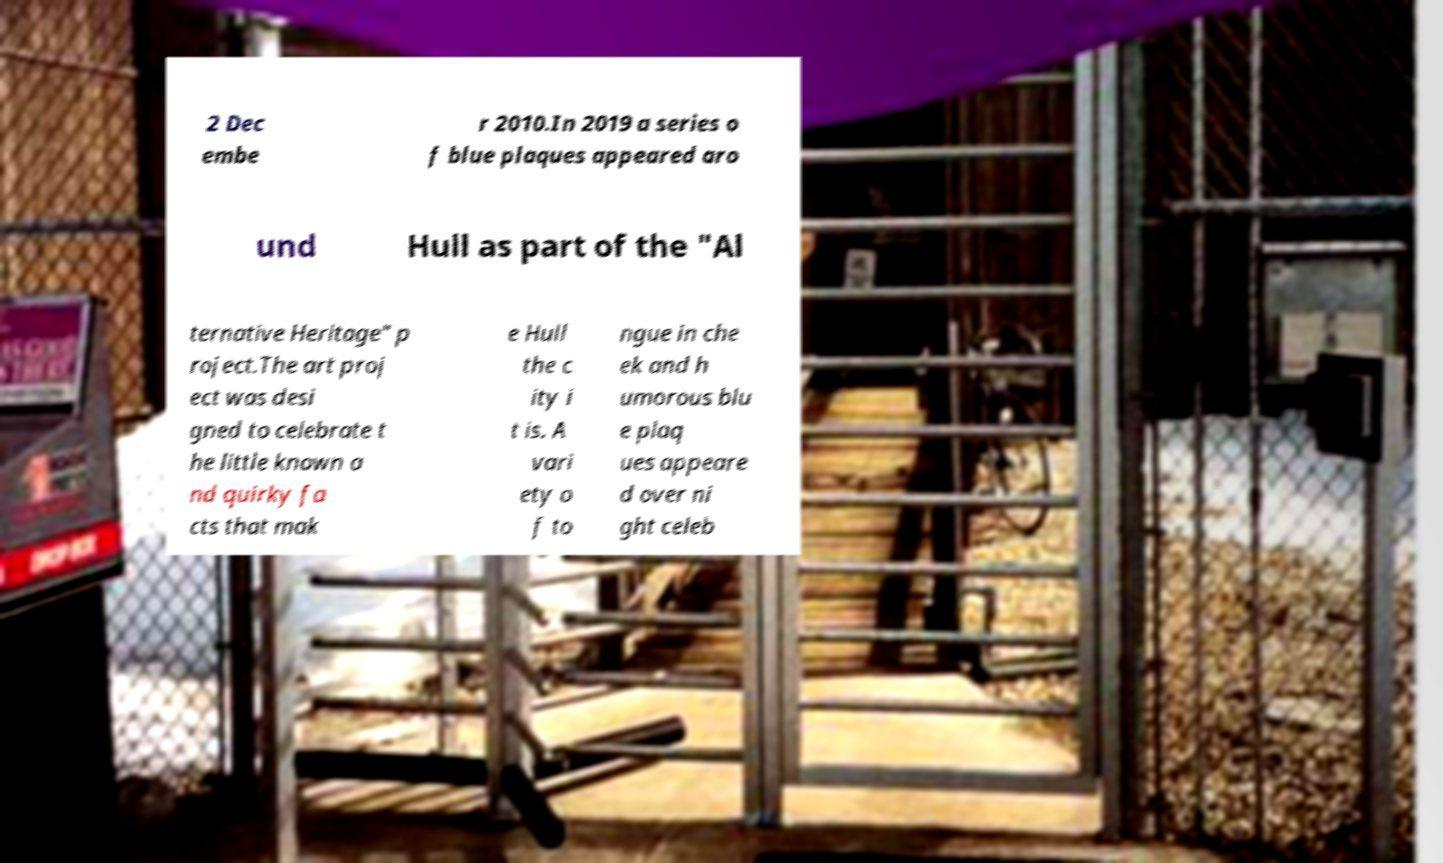I need the written content from this picture converted into text. Can you do that? 2 Dec embe r 2010.In 2019 a series o f blue plaques appeared aro und Hull as part of the "Al ternative Heritage" p roject.The art proj ect was desi gned to celebrate t he little known a nd quirky fa cts that mak e Hull the c ity i t is. A vari ety o f to ngue in che ek and h umorous blu e plaq ues appeare d over ni ght celeb 